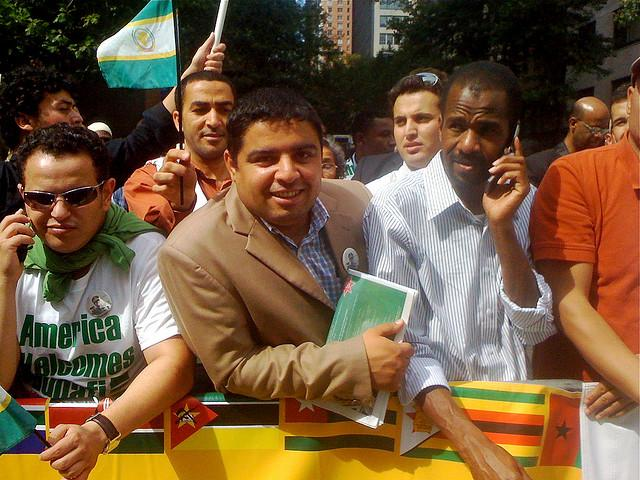What is the man holding the paper wearing? Please explain your reasoning. suit. He is wearing a tailored jacket and a collared shirt. 